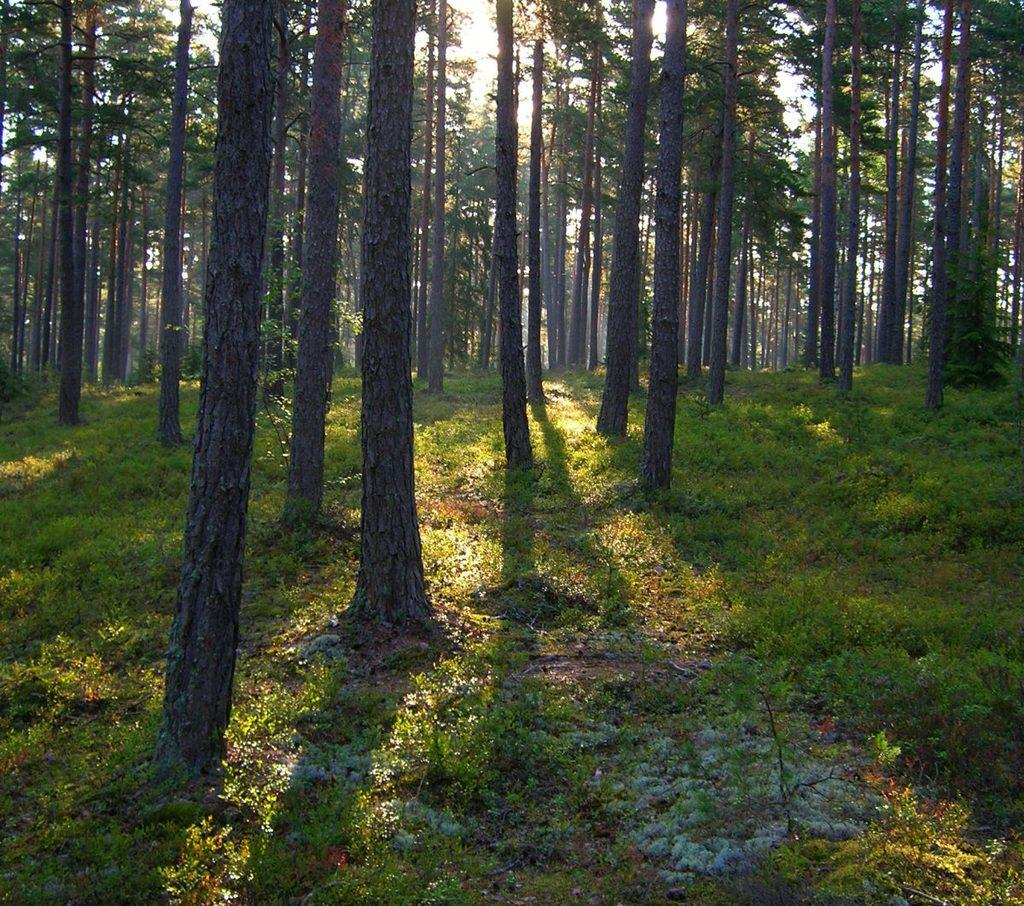What type of vegetation can be seen in the image? There is grass, plants, and trees in the image. Can you describe the natural environment depicted in the image? The image features a variety of vegetation, including grass, plants, and trees. What degree does the tramp have in the image? There is no tramp present in the image, so it is not possible to determine if they have a degree or not. 